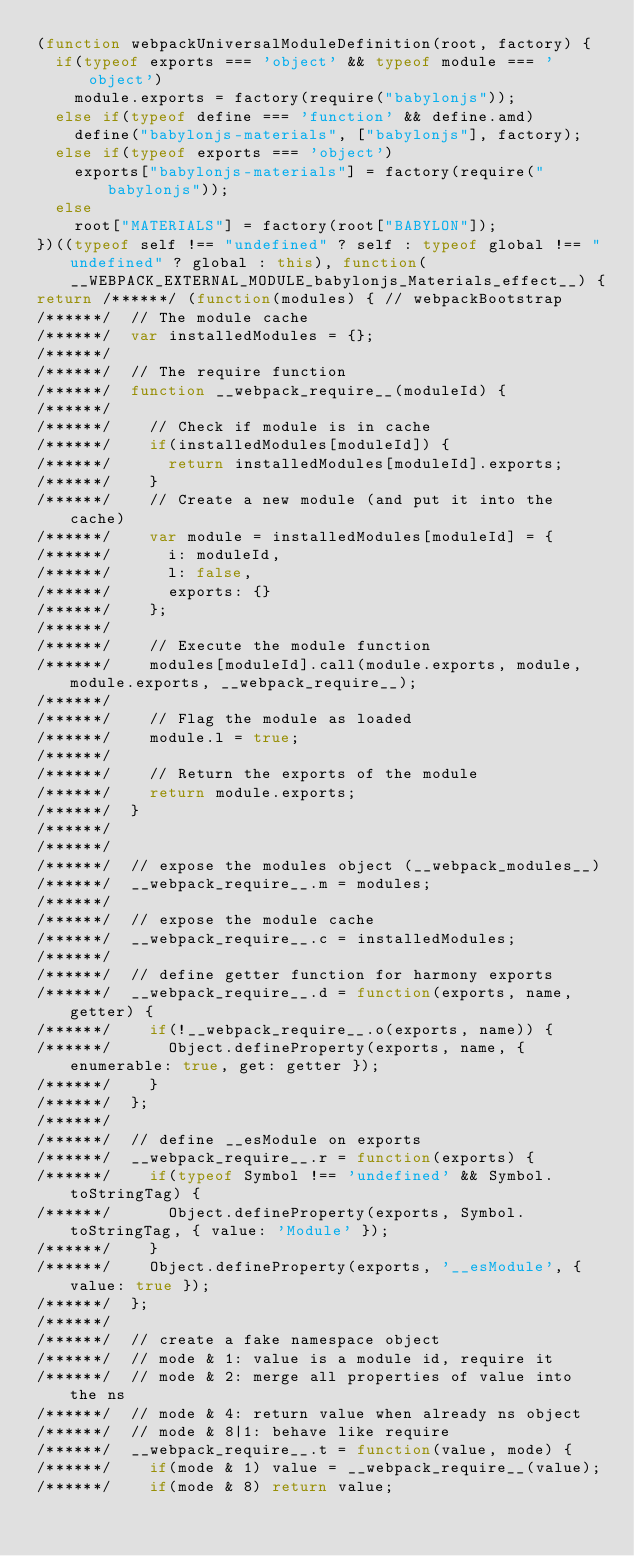Convert code to text. <code><loc_0><loc_0><loc_500><loc_500><_JavaScript_>(function webpackUniversalModuleDefinition(root, factory) {
	if(typeof exports === 'object' && typeof module === 'object')
		module.exports = factory(require("babylonjs"));
	else if(typeof define === 'function' && define.amd)
		define("babylonjs-materials", ["babylonjs"], factory);
	else if(typeof exports === 'object')
		exports["babylonjs-materials"] = factory(require("babylonjs"));
	else
		root["MATERIALS"] = factory(root["BABYLON"]);
})((typeof self !== "undefined" ? self : typeof global !== "undefined" ? global : this), function(__WEBPACK_EXTERNAL_MODULE_babylonjs_Materials_effect__) {
return /******/ (function(modules) { // webpackBootstrap
/******/ 	// The module cache
/******/ 	var installedModules = {};
/******/
/******/ 	// The require function
/******/ 	function __webpack_require__(moduleId) {
/******/
/******/ 		// Check if module is in cache
/******/ 		if(installedModules[moduleId]) {
/******/ 			return installedModules[moduleId].exports;
/******/ 		}
/******/ 		// Create a new module (and put it into the cache)
/******/ 		var module = installedModules[moduleId] = {
/******/ 			i: moduleId,
/******/ 			l: false,
/******/ 			exports: {}
/******/ 		};
/******/
/******/ 		// Execute the module function
/******/ 		modules[moduleId].call(module.exports, module, module.exports, __webpack_require__);
/******/
/******/ 		// Flag the module as loaded
/******/ 		module.l = true;
/******/
/******/ 		// Return the exports of the module
/******/ 		return module.exports;
/******/ 	}
/******/
/******/
/******/ 	// expose the modules object (__webpack_modules__)
/******/ 	__webpack_require__.m = modules;
/******/
/******/ 	// expose the module cache
/******/ 	__webpack_require__.c = installedModules;
/******/
/******/ 	// define getter function for harmony exports
/******/ 	__webpack_require__.d = function(exports, name, getter) {
/******/ 		if(!__webpack_require__.o(exports, name)) {
/******/ 			Object.defineProperty(exports, name, { enumerable: true, get: getter });
/******/ 		}
/******/ 	};
/******/
/******/ 	// define __esModule on exports
/******/ 	__webpack_require__.r = function(exports) {
/******/ 		if(typeof Symbol !== 'undefined' && Symbol.toStringTag) {
/******/ 			Object.defineProperty(exports, Symbol.toStringTag, { value: 'Module' });
/******/ 		}
/******/ 		Object.defineProperty(exports, '__esModule', { value: true });
/******/ 	};
/******/
/******/ 	// create a fake namespace object
/******/ 	// mode & 1: value is a module id, require it
/******/ 	// mode & 2: merge all properties of value into the ns
/******/ 	// mode & 4: return value when already ns object
/******/ 	// mode & 8|1: behave like require
/******/ 	__webpack_require__.t = function(value, mode) {
/******/ 		if(mode & 1) value = __webpack_require__(value);
/******/ 		if(mode & 8) return value;</code> 